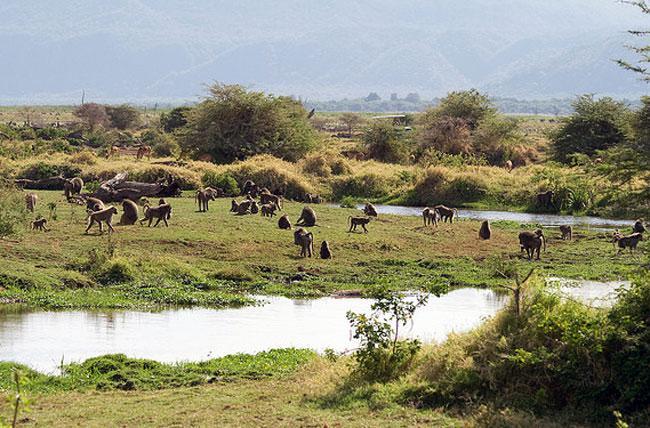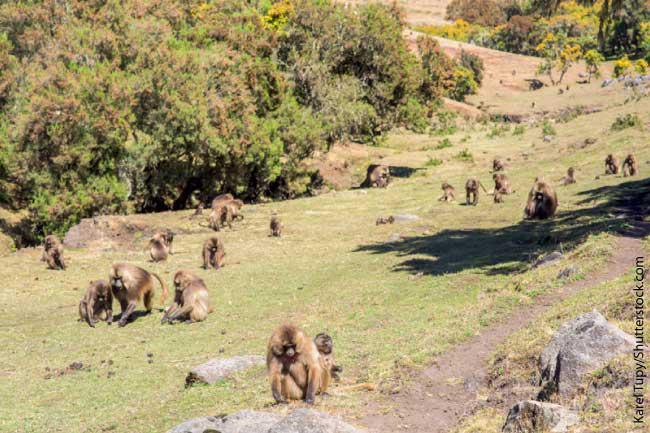The first image is the image on the left, the second image is the image on the right. Analyze the images presented: Is the assertion "Some of the animals are in a dirt path." valid? Answer yes or no. No. The first image is the image on the left, the second image is the image on the right. Assess this claim about the two images: "An image shows baboons sitting in a patch of dirt near a tree.". Correct or not? Answer yes or no. No. 